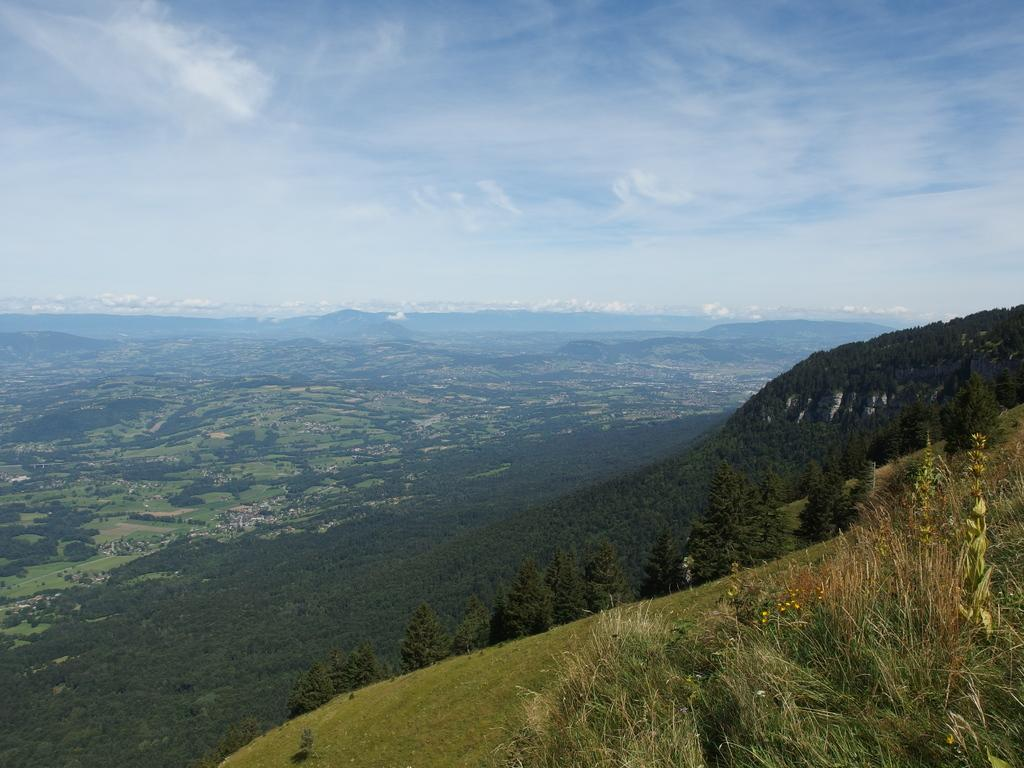What type of vegetation can be seen in the image? There are trees in the image. What is the color of the trees? The trees are green in color. What else is visible in the image besides the trees? The sky is visible in the image. What are the colors of the sky in the image? The sky is white and blue in color. What type of apparel is the tree wearing in the image? Trees do not wear apparel, so this question cannot be answered. Can you see a harbor in the image? There is no mention of a harbor in the provided facts, so it cannot be determined if one is present in the image. 